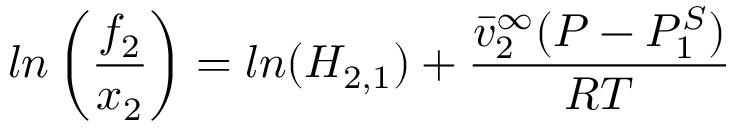Convert formula to latex. <formula><loc_0><loc_0><loc_500><loc_500>\ln \left ( \frac { f _ { 2 } } { x _ { 2 } } \right ) = \ln ( H _ { 2 , 1 } ) + \frac { \bar { v } _ { 2 } ^ { \infty } ( P - P _ { 1 } ^ { S } ) } { R T }</formula> 